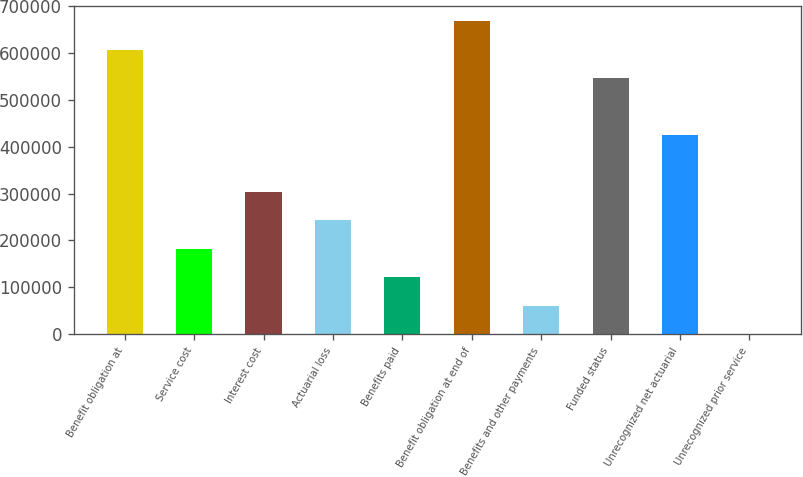Convert chart to OTSL. <chart><loc_0><loc_0><loc_500><loc_500><bar_chart><fcel>Benefit obligation at<fcel>Service cost<fcel>Interest cost<fcel>Actuarial loss<fcel>Benefits paid<fcel>Benefit obligation at end of<fcel>Benefits and other payments<fcel>Funded status<fcel>Unrecognized net actuarial<fcel>Unrecognized prior service<nl><fcel>606411<fcel>182315<fcel>303486<fcel>242900<fcel>121730<fcel>666996<fcel>61145.1<fcel>545826<fcel>424656<fcel>560<nl></chart> 